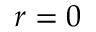Convert formula to latex. <formula><loc_0><loc_0><loc_500><loc_500>r = 0</formula> 